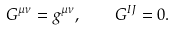Convert formula to latex. <formula><loc_0><loc_0><loc_500><loc_500>G ^ { \mu \nu } = g ^ { \mu \nu } , \quad G ^ { I J } = 0 .</formula> 